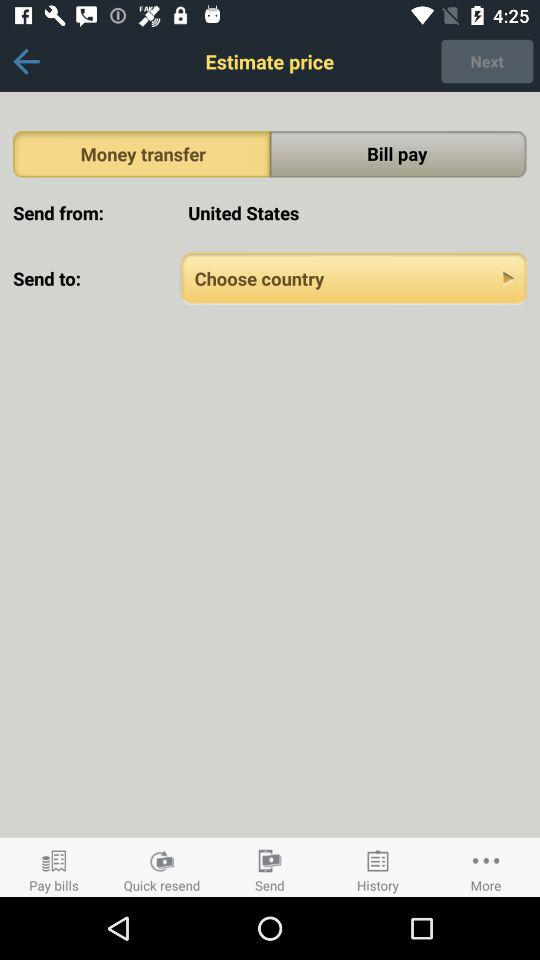Which tab is selected? The selected tab is "Money transfer". 